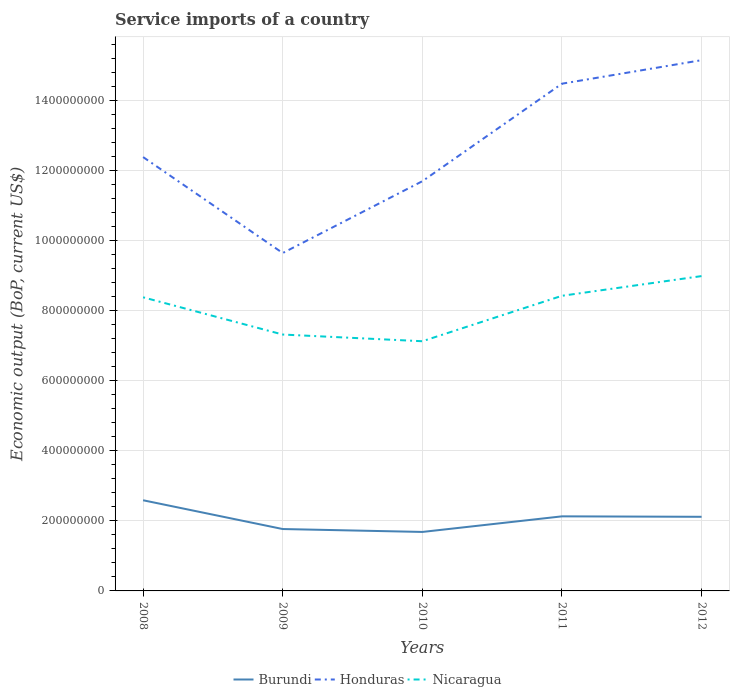Across all years, what is the maximum service imports in Nicaragua?
Your response must be concise. 7.13e+08. What is the total service imports in Burundi in the graph?
Provide a succinct answer. -3.62e+07. What is the difference between the highest and the second highest service imports in Honduras?
Your response must be concise. 5.51e+08. Is the service imports in Honduras strictly greater than the service imports in Burundi over the years?
Ensure brevity in your answer.  No. How many lines are there?
Ensure brevity in your answer.  3. How many years are there in the graph?
Ensure brevity in your answer.  5. Does the graph contain any zero values?
Make the answer very short. No. Does the graph contain grids?
Your answer should be very brief. Yes. Where does the legend appear in the graph?
Make the answer very short. Bottom center. How many legend labels are there?
Ensure brevity in your answer.  3. How are the legend labels stacked?
Your answer should be very brief. Horizontal. What is the title of the graph?
Ensure brevity in your answer.  Service imports of a country. Does "Algeria" appear as one of the legend labels in the graph?
Keep it short and to the point. No. What is the label or title of the X-axis?
Your response must be concise. Years. What is the label or title of the Y-axis?
Give a very brief answer. Economic output (BoP, current US$). What is the Economic output (BoP, current US$) in Burundi in 2008?
Give a very brief answer. 2.59e+08. What is the Economic output (BoP, current US$) in Honduras in 2008?
Your answer should be very brief. 1.24e+09. What is the Economic output (BoP, current US$) in Nicaragua in 2008?
Ensure brevity in your answer.  8.38e+08. What is the Economic output (BoP, current US$) in Burundi in 2009?
Your response must be concise. 1.77e+08. What is the Economic output (BoP, current US$) in Honduras in 2009?
Your answer should be compact. 9.64e+08. What is the Economic output (BoP, current US$) of Nicaragua in 2009?
Give a very brief answer. 7.32e+08. What is the Economic output (BoP, current US$) in Burundi in 2010?
Your response must be concise. 1.68e+08. What is the Economic output (BoP, current US$) in Honduras in 2010?
Keep it short and to the point. 1.17e+09. What is the Economic output (BoP, current US$) of Nicaragua in 2010?
Offer a terse response. 7.13e+08. What is the Economic output (BoP, current US$) of Burundi in 2011?
Keep it short and to the point. 2.13e+08. What is the Economic output (BoP, current US$) of Honduras in 2011?
Your response must be concise. 1.45e+09. What is the Economic output (BoP, current US$) of Nicaragua in 2011?
Your response must be concise. 8.42e+08. What is the Economic output (BoP, current US$) of Burundi in 2012?
Ensure brevity in your answer.  2.12e+08. What is the Economic output (BoP, current US$) in Honduras in 2012?
Provide a succinct answer. 1.51e+09. What is the Economic output (BoP, current US$) of Nicaragua in 2012?
Provide a succinct answer. 8.99e+08. Across all years, what is the maximum Economic output (BoP, current US$) in Burundi?
Make the answer very short. 2.59e+08. Across all years, what is the maximum Economic output (BoP, current US$) in Honduras?
Provide a short and direct response. 1.51e+09. Across all years, what is the maximum Economic output (BoP, current US$) in Nicaragua?
Your answer should be compact. 8.99e+08. Across all years, what is the minimum Economic output (BoP, current US$) in Burundi?
Give a very brief answer. 1.68e+08. Across all years, what is the minimum Economic output (BoP, current US$) in Honduras?
Make the answer very short. 9.64e+08. Across all years, what is the minimum Economic output (BoP, current US$) in Nicaragua?
Ensure brevity in your answer.  7.13e+08. What is the total Economic output (BoP, current US$) of Burundi in the graph?
Keep it short and to the point. 1.03e+09. What is the total Economic output (BoP, current US$) in Honduras in the graph?
Your answer should be very brief. 6.34e+09. What is the total Economic output (BoP, current US$) in Nicaragua in the graph?
Make the answer very short. 4.02e+09. What is the difference between the Economic output (BoP, current US$) of Burundi in 2008 and that in 2009?
Provide a short and direct response. 8.21e+07. What is the difference between the Economic output (BoP, current US$) of Honduras in 2008 and that in 2009?
Provide a short and direct response. 2.74e+08. What is the difference between the Economic output (BoP, current US$) in Nicaragua in 2008 and that in 2009?
Make the answer very short. 1.06e+08. What is the difference between the Economic output (BoP, current US$) in Burundi in 2008 and that in 2010?
Your answer should be compact. 9.04e+07. What is the difference between the Economic output (BoP, current US$) of Honduras in 2008 and that in 2010?
Provide a short and direct response. 6.89e+07. What is the difference between the Economic output (BoP, current US$) of Nicaragua in 2008 and that in 2010?
Give a very brief answer. 1.25e+08. What is the difference between the Economic output (BoP, current US$) in Burundi in 2008 and that in 2011?
Give a very brief answer. 4.59e+07. What is the difference between the Economic output (BoP, current US$) of Honduras in 2008 and that in 2011?
Give a very brief answer. -2.09e+08. What is the difference between the Economic output (BoP, current US$) in Nicaragua in 2008 and that in 2011?
Your answer should be compact. -4.30e+06. What is the difference between the Economic output (BoP, current US$) of Burundi in 2008 and that in 2012?
Keep it short and to the point. 4.72e+07. What is the difference between the Economic output (BoP, current US$) in Honduras in 2008 and that in 2012?
Your answer should be compact. -2.77e+08. What is the difference between the Economic output (BoP, current US$) in Nicaragua in 2008 and that in 2012?
Provide a short and direct response. -6.05e+07. What is the difference between the Economic output (BoP, current US$) in Burundi in 2009 and that in 2010?
Ensure brevity in your answer.  8.29e+06. What is the difference between the Economic output (BoP, current US$) in Honduras in 2009 and that in 2010?
Ensure brevity in your answer.  -2.05e+08. What is the difference between the Economic output (BoP, current US$) in Nicaragua in 2009 and that in 2010?
Ensure brevity in your answer.  1.91e+07. What is the difference between the Economic output (BoP, current US$) of Burundi in 2009 and that in 2011?
Offer a very short reply. -3.62e+07. What is the difference between the Economic output (BoP, current US$) in Honduras in 2009 and that in 2011?
Provide a succinct answer. -4.83e+08. What is the difference between the Economic output (BoP, current US$) in Nicaragua in 2009 and that in 2011?
Your response must be concise. -1.11e+08. What is the difference between the Economic output (BoP, current US$) of Burundi in 2009 and that in 2012?
Your answer should be compact. -3.49e+07. What is the difference between the Economic output (BoP, current US$) of Honduras in 2009 and that in 2012?
Ensure brevity in your answer.  -5.51e+08. What is the difference between the Economic output (BoP, current US$) in Nicaragua in 2009 and that in 2012?
Your answer should be compact. -1.67e+08. What is the difference between the Economic output (BoP, current US$) in Burundi in 2010 and that in 2011?
Make the answer very short. -4.45e+07. What is the difference between the Economic output (BoP, current US$) in Honduras in 2010 and that in 2011?
Provide a short and direct response. -2.78e+08. What is the difference between the Economic output (BoP, current US$) in Nicaragua in 2010 and that in 2011?
Your answer should be very brief. -1.30e+08. What is the difference between the Economic output (BoP, current US$) in Burundi in 2010 and that in 2012?
Provide a succinct answer. -4.32e+07. What is the difference between the Economic output (BoP, current US$) of Honduras in 2010 and that in 2012?
Ensure brevity in your answer.  -3.46e+08. What is the difference between the Economic output (BoP, current US$) of Nicaragua in 2010 and that in 2012?
Keep it short and to the point. -1.86e+08. What is the difference between the Economic output (BoP, current US$) of Burundi in 2011 and that in 2012?
Keep it short and to the point. 1.27e+06. What is the difference between the Economic output (BoP, current US$) of Honduras in 2011 and that in 2012?
Offer a terse response. -6.71e+07. What is the difference between the Economic output (BoP, current US$) of Nicaragua in 2011 and that in 2012?
Your response must be concise. -5.62e+07. What is the difference between the Economic output (BoP, current US$) in Burundi in 2008 and the Economic output (BoP, current US$) in Honduras in 2009?
Provide a short and direct response. -7.06e+08. What is the difference between the Economic output (BoP, current US$) in Burundi in 2008 and the Economic output (BoP, current US$) in Nicaragua in 2009?
Make the answer very short. -4.73e+08. What is the difference between the Economic output (BoP, current US$) in Honduras in 2008 and the Economic output (BoP, current US$) in Nicaragua in 2009?
Your answer should be very brief. 5.07e+08. What is the difference between the Economic output (BoP, current US$) in Burundi in 2008 and the Economic output (BoP, current US$) in Honduras in 2010?
Offer a terse response. -9.11e+08. What is the difference between the Economic output (BoP, current US$) of Burundi in 2008 and the Economic output (BoP, current US$) of Nicaragua in 2010?
Provide a short and direct response. -4.54e+08. What is the difference between the Economic output (BoP, current US$) of Honduras in 2008 and the Economic output (BoP, current US$) of Nicaragua in 2010?
Your response must be concise. 5.26e+08. What is the difference between the Economic output (BoP, current US$) of Burundi in 2008 and the Economic output (BoP, current US$) of Honduras in 2011?
Give a very brief answer. -1.19e+09. What is the difference between the Economic output (BoP, current US$) in Burundi in 2008 and the Economic output (BoP, current US$) in Nicaragua in 2011?
Make the answer very short. -5.84e+08. What is the difference between the Economic output (BoP, current US$) in Honduras in 2008 and the Economic output (BoP, current US$) in Nicaragua in 2011?
Offer a terse response. 3.96e+08. What is the difference between the Economic output (BoP, current US$) of Burundi in 2008 and the Economic output (BoP, current US$) of Honduras in 2012?
Your answer should be very brief. -1.26e+09. What is the difference between the Economic output (BoP, current US$) in Burundi in 2008 and the Economic output (BoP, current US$) in Nicaragua in 2012?
Make the answer very short. -6.40e+08. What is the difference between the Economic output (BoP, current US$) in Honduras in 2008 and the Economic output (BoP, current US$) in Nicaragua in 2012?
Your answer should be very brief. 3.40e+08. What is the difference between the Economic output (BoP, current US$) in Burundi in 2009 and the Economic output (BoP, current US$) in Honduras in 2010?
Ensure brevity in your answer.  -9.93e+08. What is the difference between the Economic output (BoP, current US$) in Burundi in 2009 and the Economic output (BoP, current US$) in Nicaragua in 2010?
Provide a succinct answer. -5.36e+08. What is the difference between the Economic output (BoP, current US$) in Honduras in 2009 and the Economic output (BoP, current US$) in Nicaragua in 2010?
Provide a short and direct response. 2.52e+08. What is the difference between the Economic output (BoP, current US$) of Burundi in 2009 and the Economic output (BoP, current US$) of Honduras in 2011?
Your answer should be very brief. -1.27e+09. What is the difference between the Economic output (BoP, current US$) of Burundi in 2009 and the Economic output (BoP, current US$) of Nicaragua in 2011?
Keep it short and to the point. -6.66e+08. What is the difference between the Economic output (BoP, current US$) in Honduras in 2009 and the Economic output (BoP, current US$) in Nicaragua in 2011?
Ensure brevity in your answer.  1.22e+08. What is the difference between the Economic output (BoP, current US$) in Burundi in 2009 and the Economic output (BoP, current US$) in Honduras in 2012?
Give a very brief answer. -1.34e+09. What is the difference between the Economic output (BoP, current US$) in Burundi in 2009 and the Economic output (BoP, current US$) in Nicaragua in 2012?
Your response must be concise. -7.22e+08. What is the difference between the Economic output (BoP, current US$) of Honduras in 2009 and the Economic output (BoP, current US$) of Nicaragua in 2012?
Your answer should be very brief. 6.58e+07. What is the difference between the Economic output (BoP, current US$) in Burundi in 2010 and the Economic output (BoP, current US$) in Honduras in 2011?
Offer a very short reply. -1.28e+09. What is the difference between the Economic output (BoP, current US$) of Burundi in 2010 and the Economic output (BoP, current US$) of Nicaragua in 2011?
Your answer should be very brief. -6.74e+08. What is the difference between the Economic output (BoP, current US$) of Honduras in 2010 and the Economic output (BoP, current US$) of Nicaragua in 2011?
Your answer should be very brief. 3.27e+08. What is the difference between the Economic output (BoP, current US$) of Burundi in 2010 and the Economic output (BoP, current US$) of Honduras in 2012?
Your answer should be very brief. -1.35e+09. What is the difference between the Economic output (BoP, current US$) in Burundi in 2010 and the Economic output (BoP, current US$) in Nicaragua in 2012?
Your answer should be compact. -7.30e+08. What is the difference between the Economic output (BoP, current US$) of Honduras in 2010 and the Economic output (BoP, current US$) of Nicaragua in 2012?
Your answer should be compact. 2.71e+08. What is the difference between the Economic output (BoP, current US$) of Burundi in 2011 and the Economic output (BoP, current US$) of Honduras in 2012?
Offer a very short reply. -1.30e+09. What is the difference between the Economic output (BoP, current US$) of Burundi in 2011 and the Economic output (BoP, current US$) of Nicaragua in 2012?
Your answer should be very brief. -6.86e+08. What is the difference between the Economic output (BoP, current US$) of Honduras in 2011 and the Economic output (BoP, current US$) of Nicaragua in 2012?
Offer a terse response. 5.49e+08. What is the average Economic output (BoP, current US$) in Burundi per year?
Offer a very short reply. 2.06e+08. What is the average Economic output (BoP, current US$) of Honduras per year?
Make the answer very short. 1.27e+09. What is the average Economic output (BoP, current US$) of Nicaragua per year?
Offer a terse response. 8.05e+08. In the year 2008, what is the difference between the Economic output (BoP, current US$) in Burundi and Economic output (BoP, current US$) in Honduras?
Offer a terse response. -9.80e+08. In the year 2008, what is the difference between the Economic output (BoP, current US$) of Burundi and Economic output (BoP, current US$) of Nicaragua?
Provide a succinct answer. -5.79e+08. In the year 2008, what is the difference between the Economic output (BoP, current US$) in Honduras and Economic output (BoP, current US$) in Nicaragua?
Give a very brief answer. 4.00e+08. In the year 2009, what is the difference between the Economic output (BoP, current US$) in Burundi and Economic output (BoP, current US$) in Honduras?
Keep it short and to the point. -7.88e+08. In the year 2009, what is the difference between the Economic output (BoP, current US$) of Burundi and Economic output (BoP, current US$) of Nicaragua?
Your answer should be very brief. -5.55e+08. In the year 2009, what is the difference between the Economic output (BoP, current US$) in Honduras and Economic output (BoP, current US$) in Nicaragua?
Give a very brief answer. 2.33e+08. In the year 2010, what is the difference between the Economic output (BoP, current US$) in Burundi and Economic output (BoP, current US$) in Honduras?
Keep it short and to the point. -1.00e+09. In the year 2010, what is the difference between the Economic output (BoP, current US$) of Burundi and Economic output (BoP, current US$) of Nicaragua?
Your answer should be very brief. -5.44e+08. In the year 2010, what is the difference between the Economic output (BoP, current US$) of Honduras and Economic output (BoP, current US$) of Nicaragua?
Make the answer very short. 4.57e+08. In the year 2011, what is the difference between the Economic output (BoP, current US$) of Burundi and Economic output (BoP, current US$) of Honduras?
Ensure brevity in your answer.  -1.23e+09. In the year 2011, what is the difference between the Economic output (BoP, current US$) of Burundi and Economic output (BoP, current US$) of Nicaragua?
Your response must be concise. -6.30e+08. In the year 2011, what is the difference between the Economic output (BoP, current US$) of Honduras and Economic output (BoP, current US$) of Nicaragua?
Make the answer very short. 6.05e+08. In the year 2012, what is the difference between the Economic output (BoP, current US$) in Burundi and Economic output (BoP, current US$) in Honduras?
Ensure brevity in your answer.  -1.30e+09. In the year 2012, what is the difference between the Economic output (BoP, current US$) in Burundi and Economic output (BoP, current US$) in Nicaragua?
Ensure brevity in your answer.  -6.87e+08. In the year 2012, what is the difference between the Economic output (BoP, current US$) of Honduras and Economic output (BoP, current US$) of Nicaragua?
Ensure brevity in your answer.  6.16e+08. What is the ratio of the Economic output (BoP, current US$) in Burundi in 2008 to that in 2009?
Give a very brief answer. 1.47. What is the ratio of the Economic output (BoP, current US$) in Honduras in 2008 to that in 2009?
Offer a terse response. 1.28. What is the ratio of the Economic output (BoP, current US$) in Nicaragua in 2008 to that in 2009?
Give a very brief answer. 1.15. What is the ratio of the Economic output (BoP, current US$) of Burundi in 2008 to that in 2010?
Ensure brevity in your answer.  1.54. What is the ratio of the Economic output (BoP, current US$) in Honduras in 2008 to that in 2010?
Make the answer very short. 1.06. What is the ratio of the Economic output (BoP, current US$) of Nicaragua in 2008 to that in 2010?
Provide a succinct answer. 1.18. What is the ratio of the Economic output (BoP, current US$) of Burundi in 2008 to that in 2011?
Give a very brief answer. 1.22. What is the ratio of the Economic output (BoP, current US$) in Honduras in 2008 to that in 2011?
Offer a terse response. 0.86. What is the ratio of the Economic output (BoP, current US$) of Nicaragua in 2008 to that in 2011?
Give a very brief answer. 0.99. What is the ratio of the Economic output (BoP, current US$) of Burundi in 2008 to that in 2012?
Your answer should be very brief. 1.22. What is the ratio of the Economic output (BoP, current US$) in Honduras in 2008 to that in 2012?
Provide a short and direct response. 0.82. What is the ratio of the Economic output (BoP, current US$) of Nicaragua in 2008 to that in 2012?
Offer a very short reply. 0.93. What is the ratio of the Economic output (BoP, current US$) of Burundi in 2009 to that in 2010?
Your answer should be compact. 1.05. What is the ratio of the Economic output (BoP, current US$) of Honduras in 2009 to that in 2010?
Your answer should be very brief. 0.82. What is the ratio of the Economic output (BoP, current US$) of Nicaragua in 2009 to that in 2010?
Your answer should be very brief. 1.03. What is the ratio of the Economic output (BoP, current US$) in Burundi in 2009 to that in 2011?
Offer a very short reply. 0.83. What is the ratio of the Economic output (BoP, current US$) in Honduras in 2009 to that in 2011?
Your response must be concise. 0.67. What is the ratio of the Economic output (BoP, current US$) of Nicaragua in 2009 to that in 2011?
Keep it short and to the point. 0.87. What is the ratio of the Economic output (BoP, current US$) of Burundi in 2009 to that in 2012?
Ensure brevity in your answer.  0.83. What is the ratio of the Economic output (BoP, current US$) of Honduras in 2009 to that in 2012?
Provide a short and direct response. 0.64. What is the ratio of the Economic output (BoP, current US$) in Nicaragua in 2009 to that in 2012?
Your response must be concise. 0.81. What is the ratio of the Economic output (BoP, current US$) in Burundi in 2010 to that in 2011?
Provide a succinct answer. 0.79. What is the ratio of the Economic output (BoP, current US$) of Honduras in 2010 to that in 2011?
Your answer should be compact. 0.81. What is the ratio of the Economic output (BoP, current US$) in Nicaragua in 2010 to that in 2011?
Your response must be concise. 0.85. What is the ratio of the Economic output (BoP, current US$) of Burundi in 2010 to that in 2012?
Give a very brief answer. 0.8. What is the ratio of the Economic output (BoP, current US$) in Honduras in 2010 to that in 2012?
Give a very brief answer. 0.77. What is the ratio of the Economic output (BoP, current US$) in Nicaragua in 2010 to that in 2012?
Offer a terse response. 0.79. What is the ratio of the Economic output (BoP, current US$) of Honduras in 2011 to that in 2012?
Provide a succinct answer. 0.96. What is the ratio of the Economic output (BoP, current US$) of Nicaragua in 2011 to that in 2012?
Offer a very short reply. 0.94. What is the difference between the highest and the second highest Economic output (BoP, current US$) in Burundi?
Offer a very short reply. 4.59e+07. What is the difference between the highest and the second highest Economic output (BoP, current US$) of Honduras?
Offer a very short reply. 6.71e+07. What is the difference between the highest and the second highest Economic output (BoP, current US$) of Nicaragua?
Your answer should be very brief. 5.62e+07. What is the difference between the highest and the lowest Economic output (BoP, current US$) of Burundi?
Ensure brevity in your answer.  9.04e+07. What is the difference between the highest and the lowest Economic output (BoP, current US$) in Honduras?
Offer a terse response. 5.51e+08. What is the difference between the highest and the lowest Economic output (BoP, current US$) in Nicaragua?
Keep it short and to the point. 1.86e+08. 